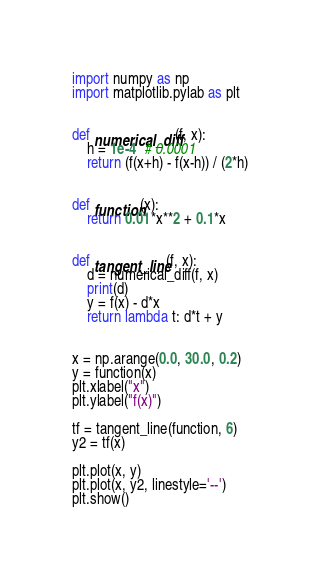Convert code to text. <code><loc_0><loc_0><loc_500><loc_500><_Python_>import numpy as np
import matplotlib.pylab as plt


def numerical_diff(f, x):
    h = 1e-4  # 0.0001
    return (f(x+h) - f(x-h)) / (2*h)


def function(x):
    return 0.01*x**2 + 0.1*x 


def tangent_line(f, x):
    d = numerical_diff(f, x)
    print(d)
    y = f(x) - d*x
    return lambda t: d*t + y


x = np.arange(0.0, 30.0, 0.2)
y = function(x)
plt.xlabel("x")
plt.ylabel("f(x)")

tf = tangent_line(function, 6)
y2 = tf(x)

plt.plot(x, y)
plt.plot(x, y2, linestyle='--')
plt.show()
</code> 